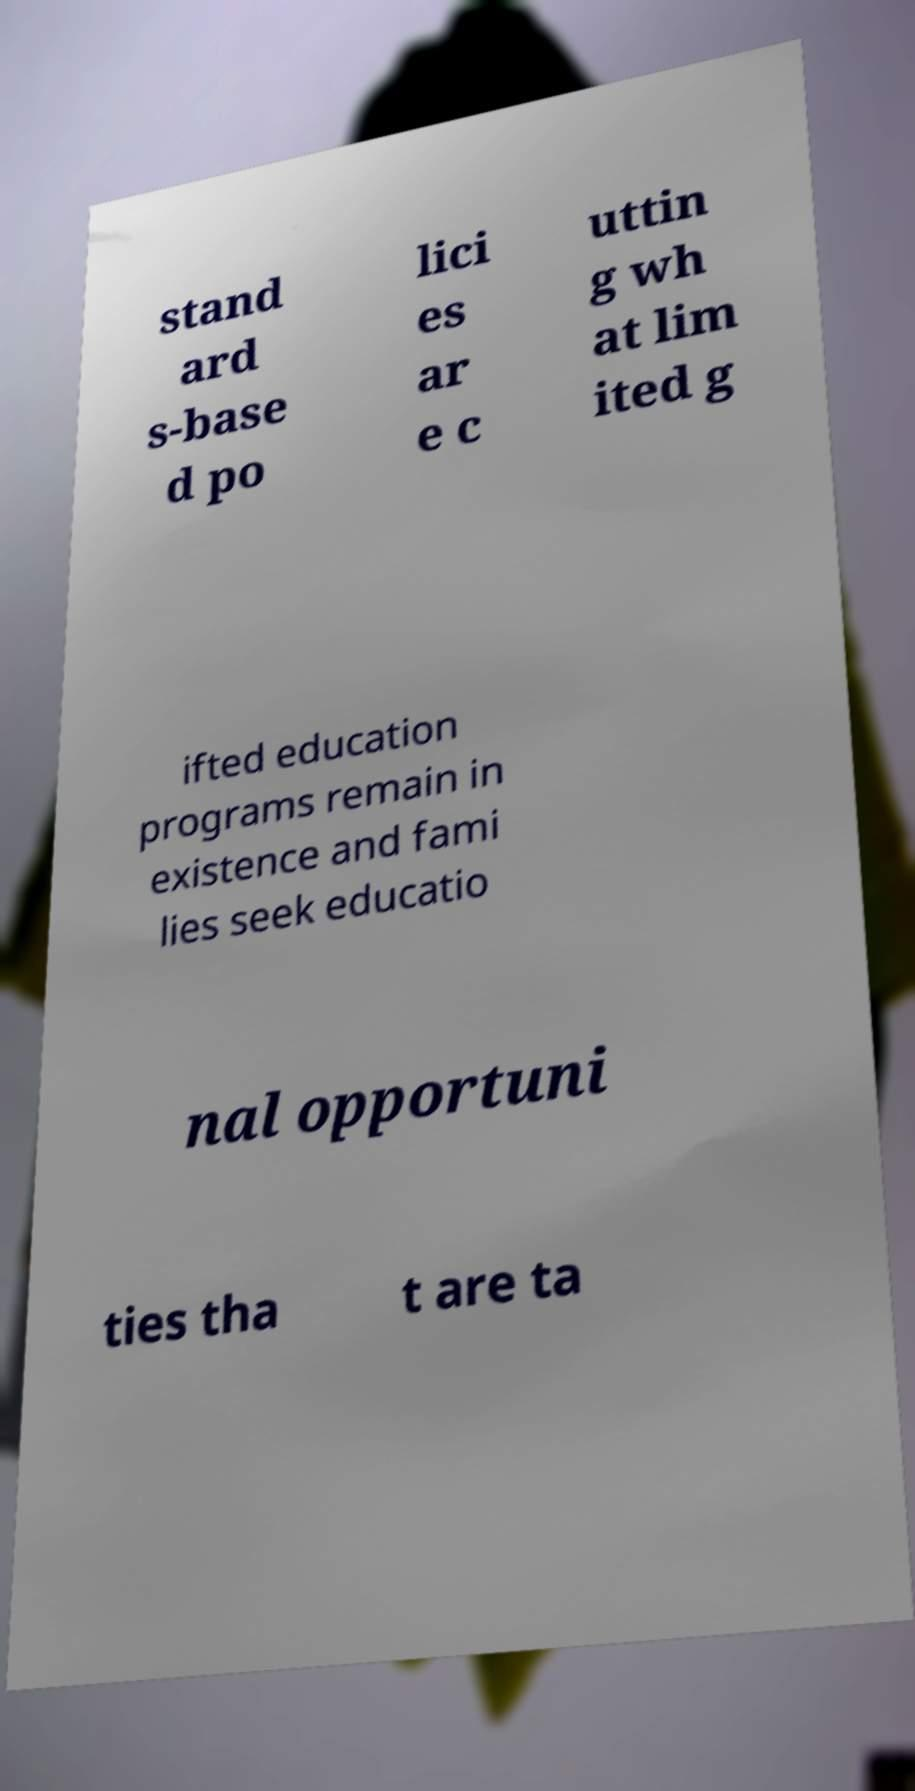For documentation purposes, I need the text within this image transcribed. Could you provide that? stand ard s-base d po lici es ar e c uttin g wh at lim ited g ifted education programs remain in existence and fami lies seek educatio nal opportuni ties tha t are ta 